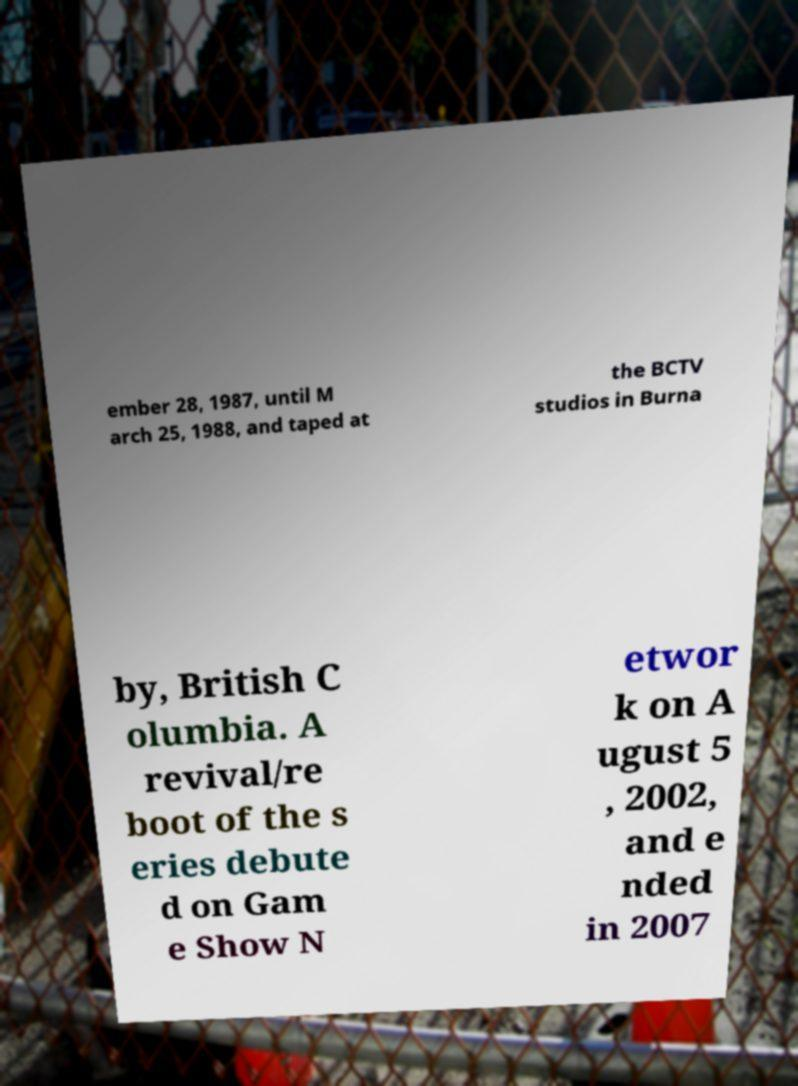Please read and relay the text visible in this image. What does it say? ember 28, 1987, until M arch 25, 1988, and taped at the BCTV studios in Burna by, British C olumbia. A revival/re boot of the s eries debute d on Gam e Show N etwor k on A ugust 5 , 2002, and e nded in 2007 